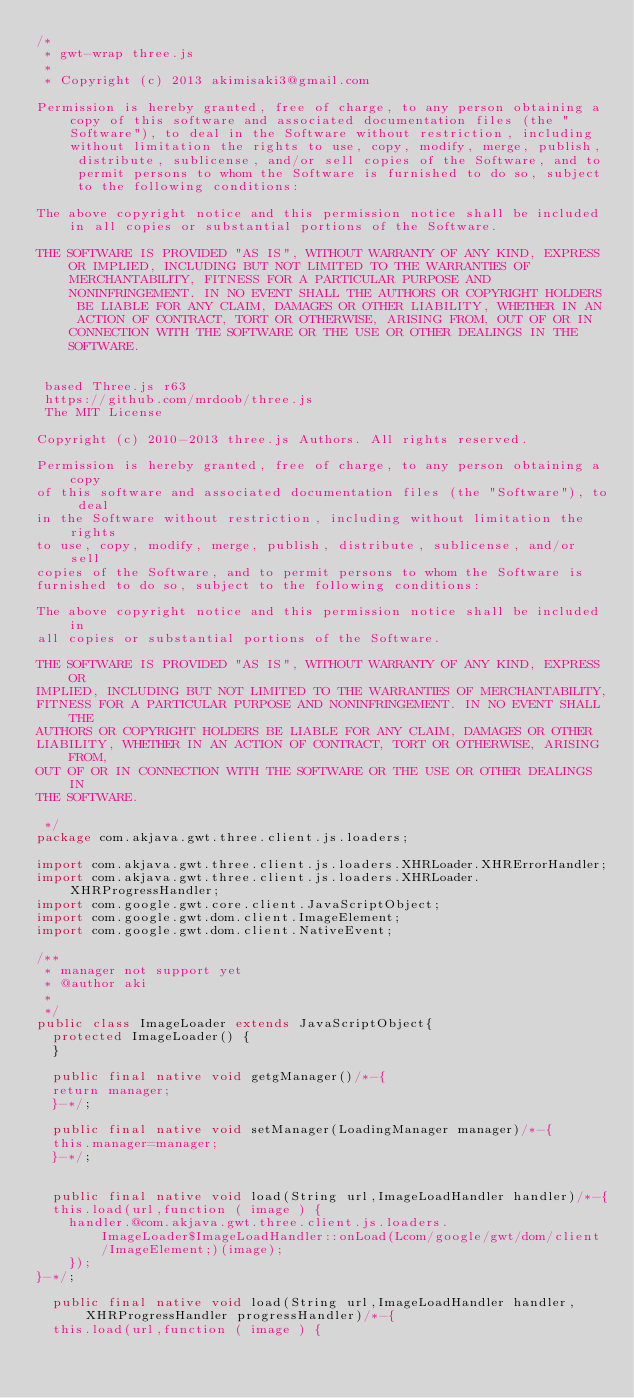Convert code to text. <code><loc_0><loc_0><loc_500><loc_500><_Java_>/*
 * gwt-wrap three.js
 * 
 * Copyright (c) 2013 akimisaki3@gmail.com

Permission is hereby granted, free of charge, to any person obtaining a copy of this software and associated documentation files (the "Software"), to deal in the Software without restriction, including without limitation the rights to use, copy, modify, merge, publish, distribute, sublicense, and/or sell copies of the Software, and to permit persons to whom the Software is furnished to do so, subject to the following conditions:

The above copyright notice and this permission notice shall be included in all copies or substantial portions of the Software.

THE SOFTWARE IS PROVIDED "AS IS", WITHOUT WARRANTY OF ANY KIND, EXPRESS OR IMPLIED, INCLUDING BUT NOT LIMITED TO THE WARRANTIES OF MERCHANTABILITY, FITNESS FOR A PARTICULAR PURPOSE AND NONINFRINGEMENT. IN NO EVENT SHALL THE AUTHORS OR COPYRIGHT HOLDERS BE LIABLE FOR ANY CLAIM, DAMAGES OR OTHER LIABILITY, WHETHER IN AN ACTION OF CONTRACT, TORT OR OTHERWISE, ARISING FROM, OUT OF OR IN CONNECTION WITH THE SOFTWARE OR THE USE OR OTHER DEALINGS IN THE SOFTWARE.
 
 
 based Three.js r63
 https://github.com/mrdoob/three.js
 The MIT License

Copyright (c) 2010-2013 three.js Authors. All rights reserved.

Permission is hereby granted, free of charge, to any person obtaining a copy
of this software and associated documentation files (the "Software"), to deal
in the Software without restriction, including without limitation the rights
to use, copy, modify, merge, publish, distribute, sublicense, and/or sell
copies of the Software, and to permit persons to whom the Software is
furnished to do so, subject to the following conditions:

The above copyright notice and this permission notice shall be included in
all copies or substantial portions of the Software.

THE SOFTWARE IS PROVIDED "AS IS", WITHOUT WARRANTY OF ANY KIND, EXPRESS OR
IMPLIED, INCLUDING BUT NOT LIMITED TO THE WARRANTIES OF MERCHANTABILITY,
FITNESS FOR A PARTICULAR PURPOSE AND NONINFRINGEMENT. IN NO EVENT SHALL THE
AUTHORS OR COPYRIGHT HOLDERS BE LIABLE FOR ANY CLAIM, DAMAGES OR OTHER
LIABILITY, WHETHER IN AN ACTION OF CONTRACT, TORT OR OTHERWISE, ARISING FROM,
OUT OF OR IN CONNECTION WITH THE SOFTWARE OR THE USE OR OTHER DEALINGS IN
THE SOFTWARE.
  
 */
package com.akjava.gwt.three.client.js.loaders;

import com.akjava.gwt.three.client.js.loaders.XHRLoader.XHRErrorHandler;
import com.akjava.gwt.three.client.js.loaders.XHRLoader.XHRProgressHandler;
import com.google.gwt.core.client.JavaScriptObject;
import com.google.gwt.dom.client.ImageElement;
import com.google.gwt.dom.client.NativeEvent;

/**
 * manager not support yet
 * @author aki
 *
 */
public class ImageLoader extends JavaScriptObject{
	protected ImageLoader() {
	}
	
	public final native void getgManager()/*-{
	return manager;
	}-*/;

	public final native void setManager(LoadingManager manager)/*-{
	this.manager=manager;
	}-*/;


	public final native void load(String url,ImageLoadHandler handler)/*-{
	this.load(url,function ( image ) {
		handler.@com.akjava.gwt.three.client.js.loaders.ImageLoader$ImageLoadHandler::onLoad(Lcom/google/gwt/dom/client/ImageElement;)(image);
		});
}-*/;
	
	public final native void load(String url,ImageLoadHandler handler,XHRProgressHandler progressHandler)/*-{
	this.load(url,function ( image ) {</code> 